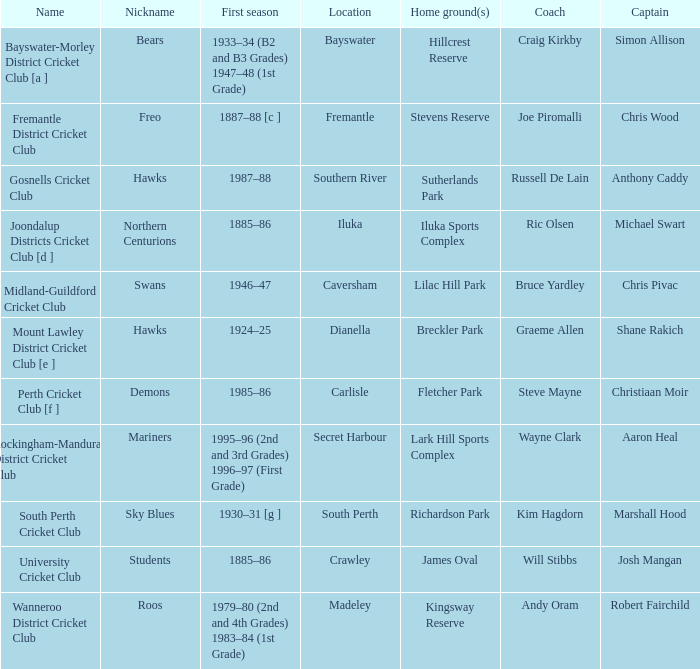What is the code nickname where Steve Mayne is the coach? Demons. 